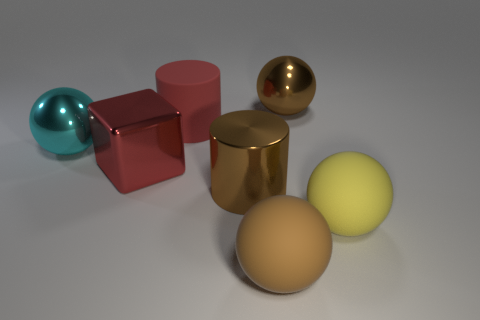What shape is the cyan metallic thing?
Your answer should be compact. Sphere. There is a brown ball behind the big brown shiny cylinder that is behind the big brown ball that is in front of the cyan sphere; what is its material?
Make the answer very short. Metal. How many other things are made of the same material as the large yellow thing?
Make the answer very short. 2. What number of shiny objects are in front of the large object on the left side of the large red metal thing?
Your answer should be compact. 2. What number of balls are big rubber things or cyan things?
Your answer should be very brief. 3. There is a large metallic object that is both right of the red metallic object and in front of the cyan shiny ball; what is its color?
Offer a very short reply. Brown. Is there anything else of the same color as the metal cylinder?
Provide a succinct answer. Yes. There is a big metallic ball to the left of the big brown ball that is to the right of the big brown matte ball; what color is it?
Your response must be concise. Cyan. Do the brown cylinder and the red matte thing have the same size?
Provide a succinct answer. Yes. Are the sphere that is left of the red cube and the red thing that is on the left side of the red rubber cylinder made of the same material?
Your response must be concise. Yes. 